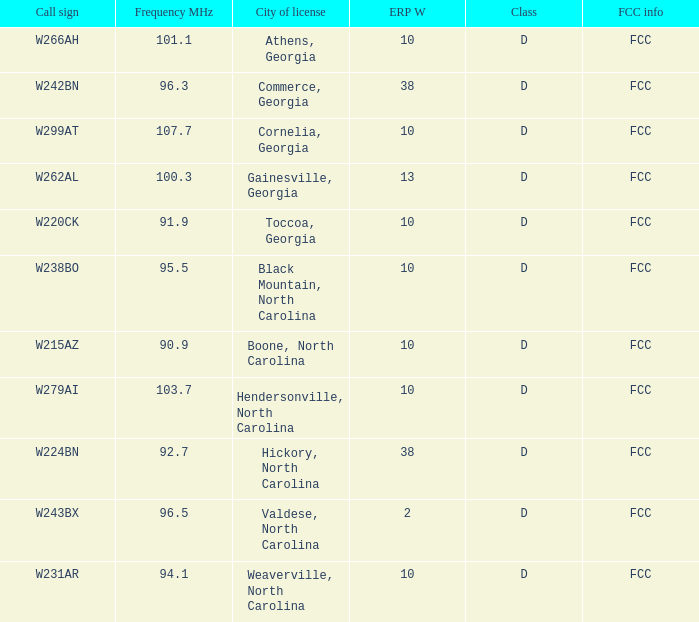What is the megahertz frequency for the station with a call sign of w224bn? 92.7. 